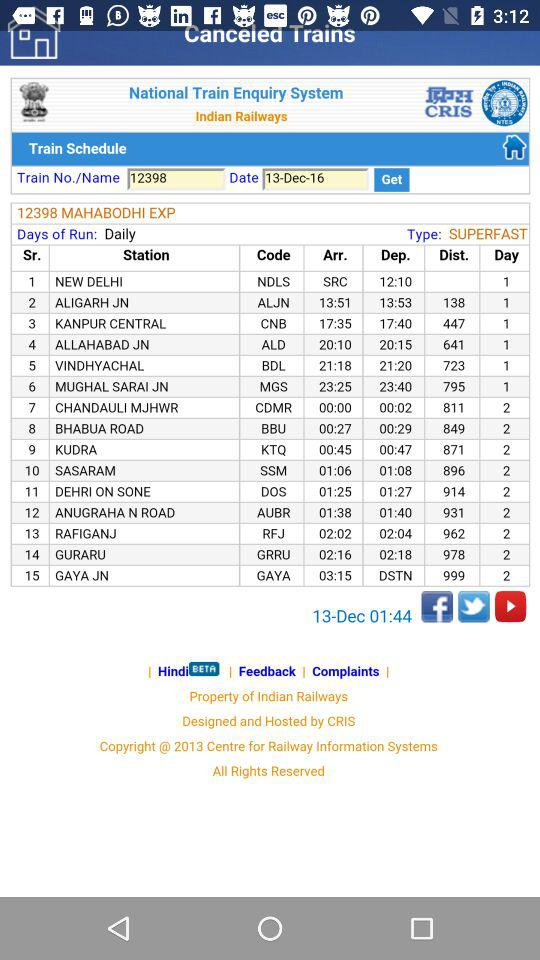What is the departure time from ALJN? The departure time is 13:53. 